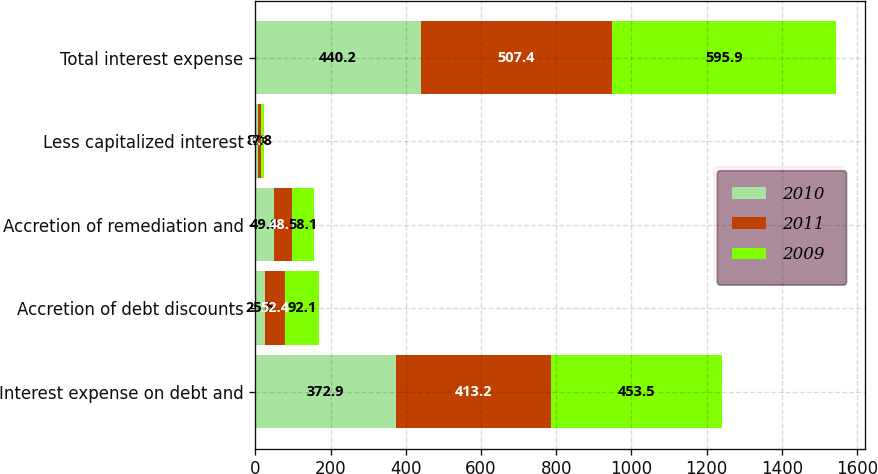Convert chart. <chart><loc_0><loc_0><loc_500><loc_500><stacked_bar_chart><ecel><fcel>Interest expense on debt and<fcel>Accretion of debt discounts<fcel>Accretion of remediation and<fcel>Less capitalized interest<fcel>Total interest expense<nl><fcel>2010<fcel>372.9<fcel>25.6<fcel>49.8<fcel>8.1<fcel>440.2<nl><fcel>2011<fcel>413.2<fcel>52.4<fcel>48.1<fcel>6.3<fcel>507.4<nl><fcel>2009<fcel>453.5<fcel>92.1<fcel>58.1<fcel>7.8<fcel>595.9<nl></chart> 